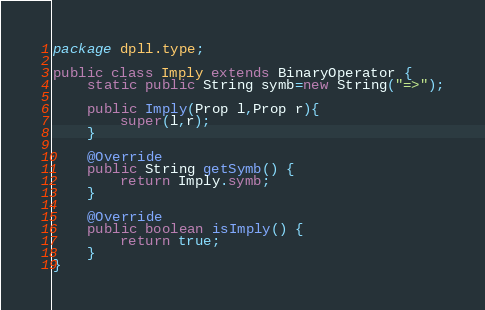<code> <loc_0><loc_0><loc_500><loc_500><_Java_>package dpll.type;

public class Imply extends BinaryOperator {
	static public String symb=new String("=>");
	
	public Imply(Prop l,Prop r){
		super(l,r);
	}
	
	@Override
	public String getSymb() {
		return Imply.symb;
	}
	
	@Override
	public boolean isImply() {
		return true;
	}
}
</code> 